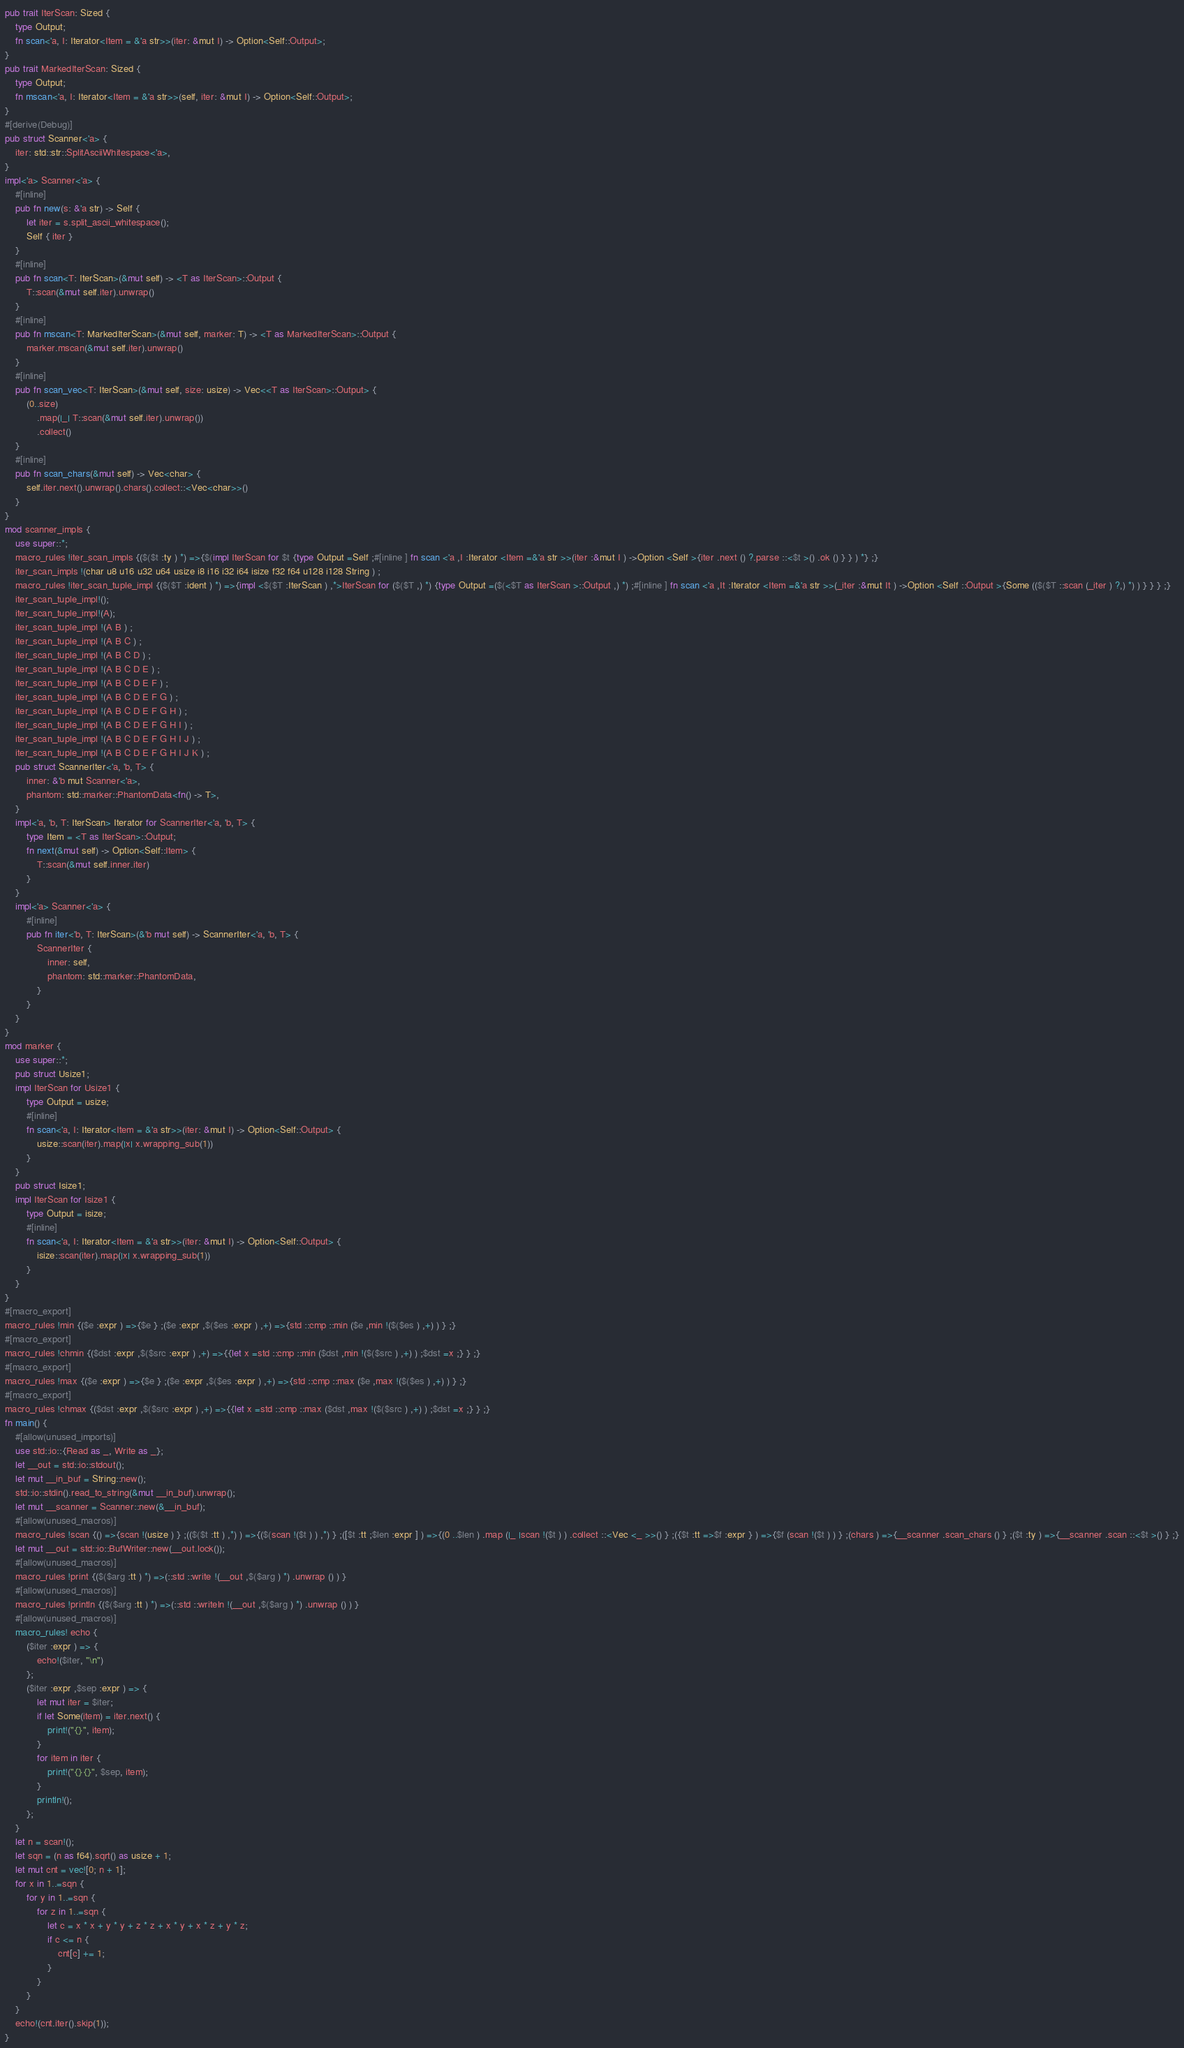Convert code to text. <code><loc_0><loc_0><loc_500><loc_500><_Rust_>pub trait IterScan: Sized {
    type Output;
    fn scan<'a, I: Iterator<Item = &'a str>>(iter: &mut I) -> Option<Self::Output>;
}
pub trait MarkedIterScan: Sized {
    type Output;
    fn mscan<'a, I: Iterator<Item = &'a str>>(self, iter: &mut I) -> Option<Self::Output>;
}
#[derive(Debug)]
pub struct Scanner<'a> {
    iter: std::str::SplitAsciiWhitespace<'a>,
}
impl<'a> Scanner<'a> {
    #[inline]
    pub fn new(s: &'a str) -> Self {
        let iter = s.split_ascii_whitespace();
        Self { iter }
    }
    #[inline]
    pub fn scan<T: IterScan>(&mut self) -> <T as IterScan>::Output {
        T::scan(&mut self.iter).unwrap()
    }
    #[inline]
    pub fn mscan<T: MarkedIterScan>(&mut self, marker: T) -> <T as MarkedIterScan>::Output {
        marker.mscan(&mut self.iter).unwrap()
    }
    #[inline]
    pub fn scan_vec<T: IterScan>(&mut self, size: usize) -> Vec<<T as IterScan>::Output> {
        (0..size)
            .map(|_| T::scan(&mut self.iter).unwrap())
            .collect()
    }
    #[inline]
    pub fn scan_chars(&mut self) -> Vec<char> {
        self.iter.next().unwrap().chars().collect::<Vec<char>>()
    }
}
mod scanner_impls {
    use super::*;
    macro_rules !iter_scan_impls {($($t :ty ) *) =>{$(impl IterScan for $t {type Output =Self ;#[inline ] fn scan <'a ,I :Iterator <Item =&'a str >>(iter :&mut I ) ->Option <Self >{iter .next () ?.parse ::<$t >() .ok () } } ) *} ;}
    iter_scan_impls !(char u8 u16 u32 u64 usize i8 i16 i32 i64 isize f32 f64 u128 i128 String ) ;
    macro_rules !iter_scan_tuple_impl {($($T :ident ) *) =>{impl <$($T :IterScan ) ,*>IterScan for ($($T ,) *) {type Output =($(<$T as IterScan >::Output ,) *) ;#[inline ] fn scan <'a ,It :Iterator <Item =&'a str >>(_iter :&mut It ) ->Option <Self ::Output >{Some (($($T ::scan (_iter ) ?,) *) ) } } } ;}
    iter_scan_tuple_impl!();
    iter_scan_tuple_impl!(A);
    iter_scan_tuple_impl !(A B ) ;
    iter_scan_tuple_impl !(A B C ) ;
    iter_scan_tuple_impl !(A B C D ) ;
    iter_scan_tuple_impl !(A B C D E ) ;
    iter_scan_tuple_impl !(A B C D E F ) ;
    iter_scan_tuple_impl !(A B C D E F G ) ;
    iter_scan_tuple_impl !(A B C D E F G H ) ;
    iter_scan_tuple_impl !(A B C D E F G H I ) ;
    iter_scan_tuple_impl !(A B C D E F G H I J ) ;
    iter_scan_tuple_impl !(A B C D E F G H I J K ) ;
    pub struct ScannerIter<'a, 'b, T> {
        inner: &'b mut Scanner<'a>,
        phantom: std::marker::PhantomData<fn() -> T>,
    }
    impl<'a, 'b, T: IterScan> Iterator for ScannerIter<'a, 'b, T> {
        type Item = <T as IterScan>::Output;
        fn next(&mut self) -> Option<Self::Item> {
            T::scan(&mut self.inner.iter)
        }
    }
    impl<'a> Scanner<'a> {
        #[inline]
        pub fn iter<'b, T: IterScan>(&'b mut self) -> ScannerIter<'a, 'b, T> {
            ScannerIter {
                inner: self,
                phantom: std::marker::PhantomData,
            }
        }
    }
}
mod marker {
    use super::*;
    pub struct Usize1;
    impl IterScan for Usize1 {
        type Output = usize;
        #[inline]
        fn scan<'a, I: Iterator<Item = &'a str>>(iter: &mut I) -> Option<Self::Output> {
            usize::scan(iter).map(|x| x.wrapping_sub(1))
        }
    }
    pub struct Isize1;
    impl IterScan for Isize1 {
        type Output = isize;
        #[inline]
        fn scan<'a, I: Iterator<Item = &'a str>>(iter: &mut I) -> Option<Self::Output> {
            isize::scan(iter).map(|x| x.wrapping_sub(1))
        }
    }
}
#[macro_export]
macro_rules !min {($e :expr ) =>{$e } ;($e :expr ,$($es :expr ) ,+) =>{std ::cmp ::min ($e ,min !($($es ) ,+) ) } ;}
#[macro_export]
macro_rules !chmin {($dst :expr ,$($src :expr ) ,+) =>{{let x =std ::cmp ::min ($dst ,min !($($src ) ,+) ) ;$dst =x ;} } ;}
#[macro_export]
macro_rules !max {($e :expr ) =>{$e } ;($e :expr ,$($es :expr ) ,+) =>{std ::cmp ::max ($e ,max !($($es ) ,+) ) } ;}
#[macro_export]
macro_rules !chmax {($dst :expr ,$($src :expr ) ,+) =>{{let x =std ::cmp ::max ($dst ,max !($($src ) ,+) ) ;$dst =x ;} } ;}
fn main() {
    #[allow(unused_imports)]
    use std::io::{Read as _, Write as _};
    let __out = std::io::stdout();
    let mut __in_buf = String::new();
    std::io::stdin().read_to_string(&mut __in_buf).unwrap();
    let mut __scanner = Scanner::new(&__in_buf);
    #[allow(unused_macros)]
    macro_rules !scan {() =>{scan !(usize ) } ;(($($t :tt ) ,*) ) =>{($(scan !($t ) ) ,*) } ;([$t :tt ;$len :expr ] ) =>{(0 ..$len ) .map (|_ |scan !($t ) ) .collect ::<Vec <_ >>() } ;({$t :tt =>$f :expr } ) =>{$f (scan !($t ) ) } ;(chars ) =>{__scanner .scan_chars () } ;($t :ty ) =>{__scanner .scan ::<$t >() } ;}
    let mut __out = std::io::BufWriter::new(__out.lock());
    #[allow(unused_macros)]
    macro_rules !print {($($arg :tt ) *) =>(::std ::write !(__out ,$($arg ) *) .unwrap () ) }
    #[allow(unused_macros)]
    macro_rules !println {($($arg :tt ) *) =>(::std ::writeln !(__out ,$($arg ) *) .unwrap () ) }
    #[allow(unused_macros)]
    macro_rules! echo {
        ($iter :expr ) => {
            echo!($iter, "\n")
        };
        ($iter :expr ,$sep :expr ) => {
            let mut iter = $iter;
            if let Some(item) = iter.next() {
                print!("{}", item);
            }
            for item in iter {
                print!("{}{}", $sep, item);
            }
            println!();
        };
    }
    let n = scan!();
    let sqn = (n as f64).sqrt() as usize + 1;
    let mut cnt = vec![0; n + 1];
    for x in 1..=sqn {
        for y in 1..=sqn {
            for z in 1..=sqn {
                let c = x * x + y * y + z * z + x * y + x * z + y * z;
                if c <= n {
                    cnt[c] += 1;
                }
            }
        }
    }
    echo!(cnt.iter().skip(1));
}</code> 